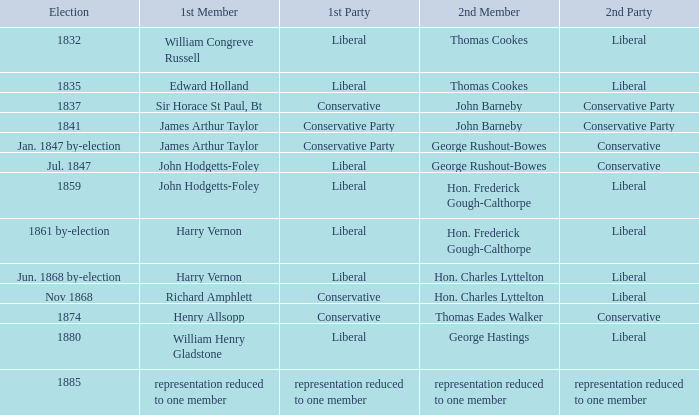What was the subsequent party when its following member was george rushout-bowes, and the initial party was liberal? Conservative. 